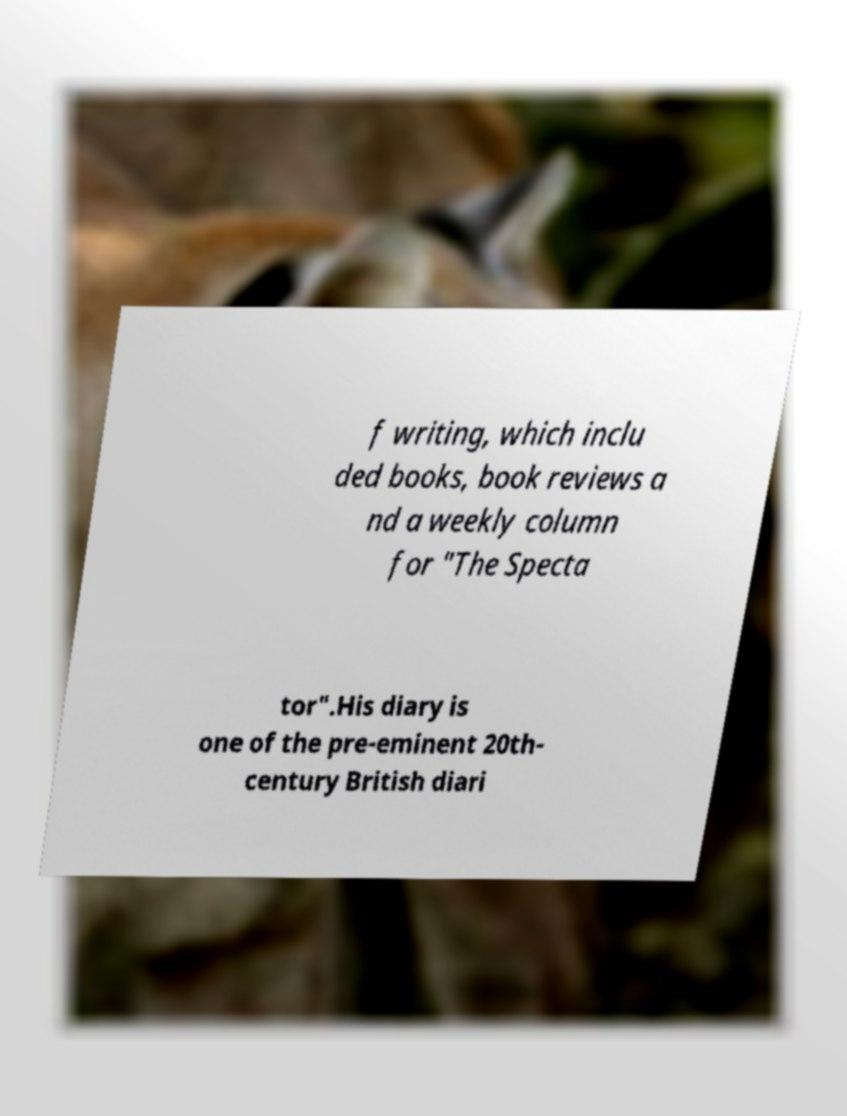Can you accurately transcribe the text from the provided image for me? f writing, which inclu ded books, book reviews a nd a weekly column for "The Specta tor".His diary is one of the pre-eminent 20th- century British diari 